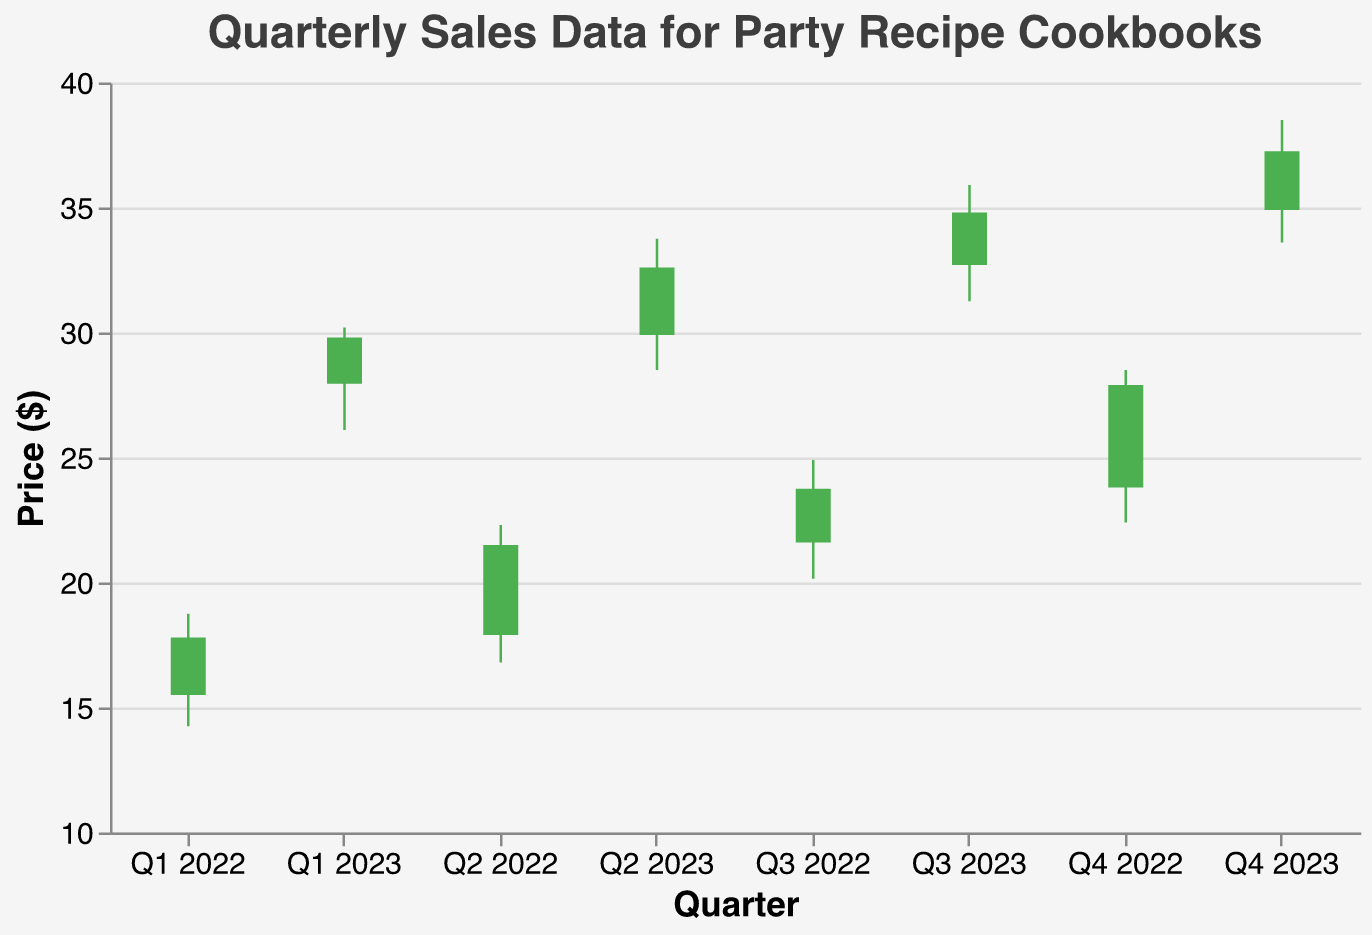What is the title of the figure? The title of the figure is displayed at the top and reads "Quarterly Sales Data for Party Recipe Cookbooks".
Answer: Quarterly Sales Data for Party Recipe Cookbooks How many quarters of data are represented in the figure? By counting the unique data points aligned on the x-axis, we see there are 8 quarters represented, from Q1 2022 to Q4 2023.
Answer: 8 What is the price range for Q4 2023? The price range can be determined by looking at the low and high values for Q4 2023. These values are 33.60 (Low) and 38.50 (High).
Answer: 33.60 to 38.50 Which quarter had the highest closing price during the observed period? By comparing the close prices for each quarter, Q4 2023 has the highest close price at 37.25.
Answer: Q4 2023 During which quarter did the sales price have the largest single-quarter increase from open to close? To determine the largest increase, calculate the difference (Close - Open) for each quarter. The largest increase is in Q4 2022: Close (27.90) - Open (23.80) = 4.10.
Answer: Q4 2022 What is the overall trend observed in the closing prices across the quarters? Observing the closing prices from Q1 2022 through Q4 2023, there is a consistent upward trend with each successive quarter showing a higher close compared to the previous quarter.
Answer: Increasing What was the opening price at the start of Q2 2022 compared to its closing price of the previous quarter, Q1 2022? The closing price for Q1 2022 is 17.80, and the opening price for Q2 2022 is 17.90.
Answer: 17.80 and 17.90 Comparing Q2 2023 and Q4 2023, which quarter experienced a higher volatility in sales price? Volatility can be examined by the range (High - Low). Q2 2023 range: 33.75 - 28.50 = 5.25, Q4 2023 range: 38.50 - 33.60 = 4.90. Q2 2023 has higher volatility.
Answer: Q2 2023 